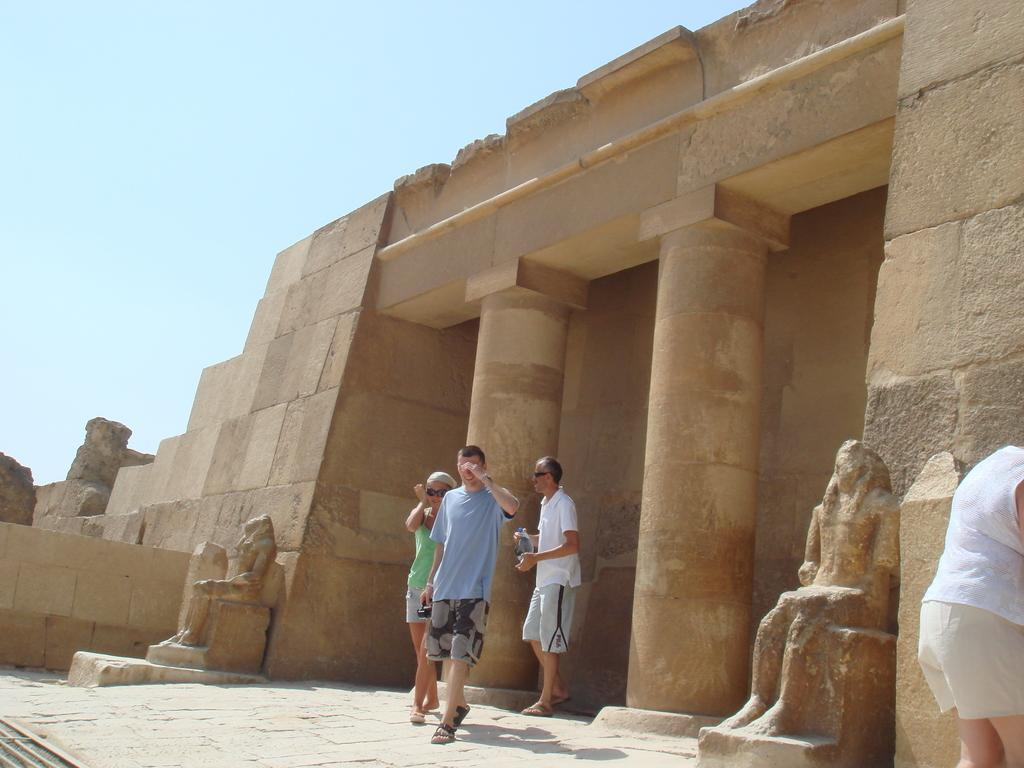How many people can be seen walking in the image? There are three people walking in the image. What surface are the people walking on? The people are walking on the ground. What can be seen in the background of the image? There is a building in the background of the image. Are there any other objects or features near the building? Yes, there are sculptures near the building. What is visible at the top of the image? The sky is visible at the top of the image. How many grapes are being held by the people walking in the image? There are no grapes visible in the image; the people are not holding any grapes. How many legs does the sculpture have in the image? There is no specific sculpture mentioned in the image, so it is not possible to determine the number of legs it has. 